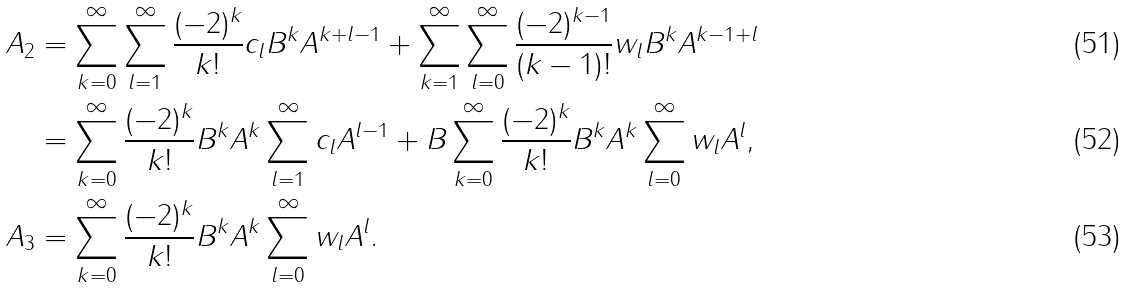Convert formula to latex. <formula><loc_0><loc_0><loc_500><loc_500>A _ { 2 } & = \sum _ { k = 0 } ^ { \infty } \sum _ { l = 1 } ^ { \infty } \frac { ( - 2 ) ^ { k } } { k ! } c _ { l } B ^ { k } A ^ { k + l - 1 } + \sum _ { k = 1 } ^ { \infty } \sum _ { l = 0 } ^ { \infty } \frac { ( - 2 ) ^ { k - 1 } } { ( k - 1 ) ! } w _ { l } B ^ { k } A ^ { k - 1 + l } \\ & = \sum _ { k = 0 } ^ { \infty } \frac { ( - 2 ) ^ { k } } { k ! } B ^ { k } A ^ { k } \sum _ { l = 1 } ^ { \infty } c _ { l } A ^ { l - 1 } + B \sum _ { k = 0 } ^ { \infty } \frac { ( - 2 ) ^ { k } } { k ! } B ^ { k } A ^ { k } \sum _ { l = 0 } ^ { \infty } w _ { l } A ^ { l } , \\ A _ { 3 } & = \sum _ { k = 0 } ^ { \infty } \frac { ( - 2 ) ^ { k } } { k ! } B ^ { k } A ^ { k } \sum _ { l = 0 } ^ { \infty } w _ { l } A ^ { l } .</formula> 